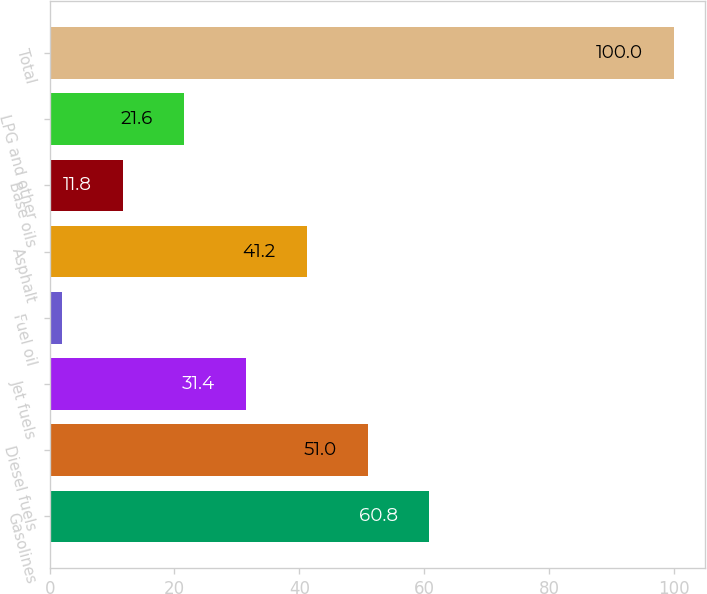<chart> <loc_0><loc_0><loc_500><loc_500><bar_chart><fcel>Gasolines<fcel>Diesel fuels<fcel>Jet fuels<fcel>Fuel oil<fcel>Asphalt<fcel>Base oils<fcel>LPG and other<fcel>Total<nl><fcel>60.8<fcel>51<fcel>31.4<fcel>2<fcel>41.2<fcel>11.8<fcel>21.6<fcel>100<nl></chart> 